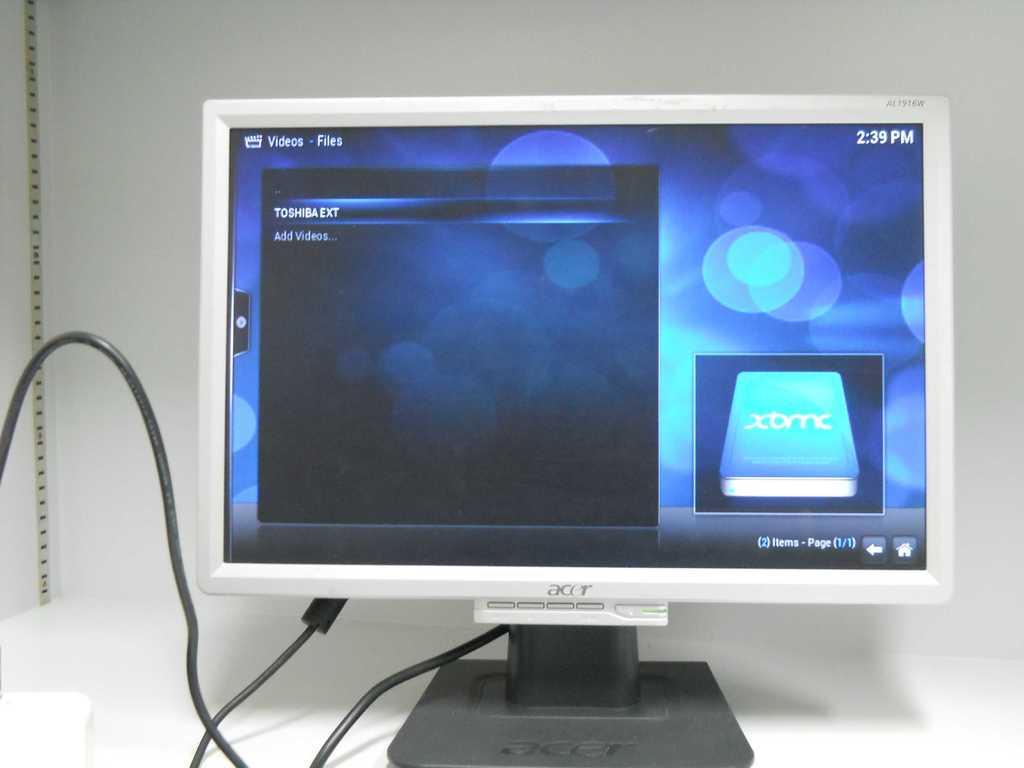What time is shown on the screen?
Keep it short and to the point. 2:39pm. What time is it?
Ensure brevity in your answer.  2:39 pm. 